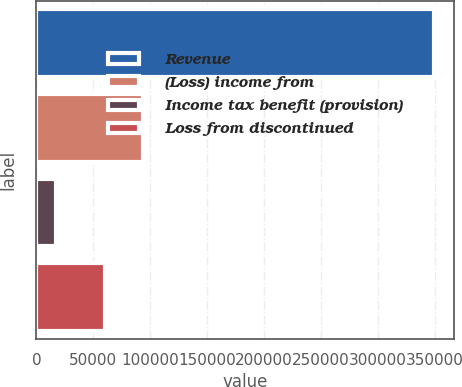Convert chart to OTSL. <chart><loc_0><loc_0><loc_500><loc_500><bar_chart><fcel>Revenue<fcel>(Loss) income from<fcel>Income tax benefit (provision)<fcel>Loss from discontinued<nl><fcel>349041<fcel>93428.9<fcel>16912<fcel>60216<nl></chart> 